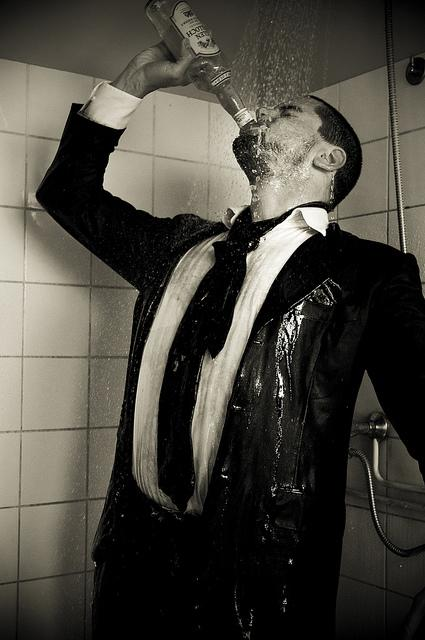What single item is most out of place?

Choices:
A) man
B) beverage
C) suit
D) shower shower 